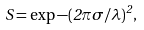<formula> <loc_0><loc_0><loc_500><loc_500>S = \exp { - ( 2 \pi \sigma / \lambda ) ^ { 2 } } ,</formula> 